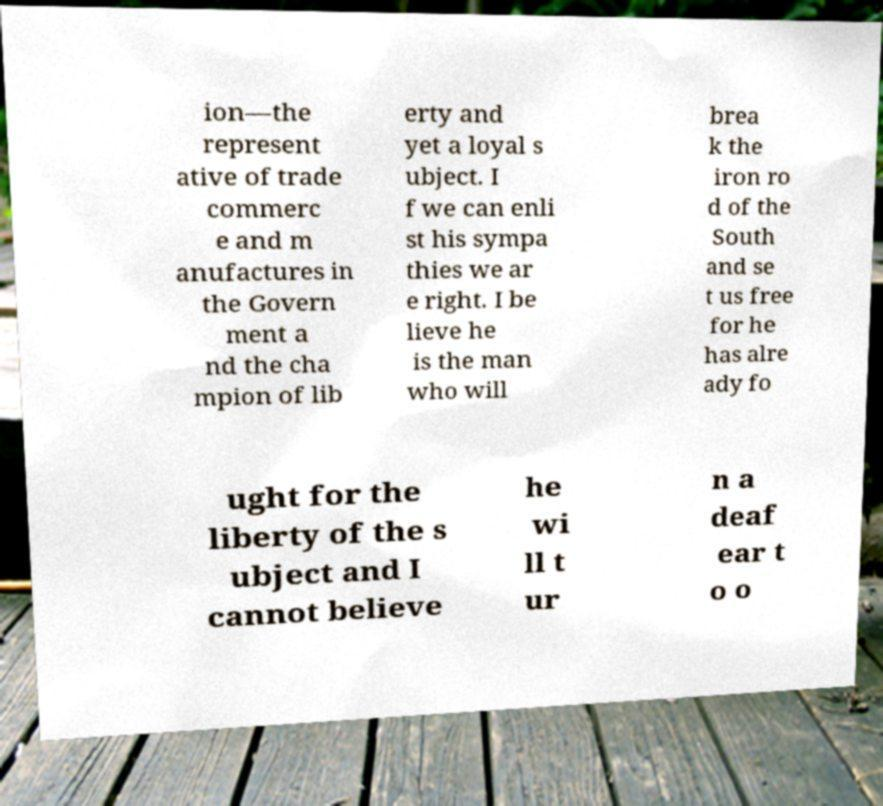For documentation purposes, I need the text within this image transcribed. Could you provide that? ion—the represent ative of trade commerc e and m anufactures in the Govern ment a nd the cha mpion of lib erty and yet a loyal s ubject. I f we can enli st his sympa thies we ar e right. I be lieve he is the man who will brea k the iron ro d of the South and se t us free for he has alre ady fo ught for the liberty of the s ubject and I cannot believe he wi ll t ur n a deaf ear t o o 